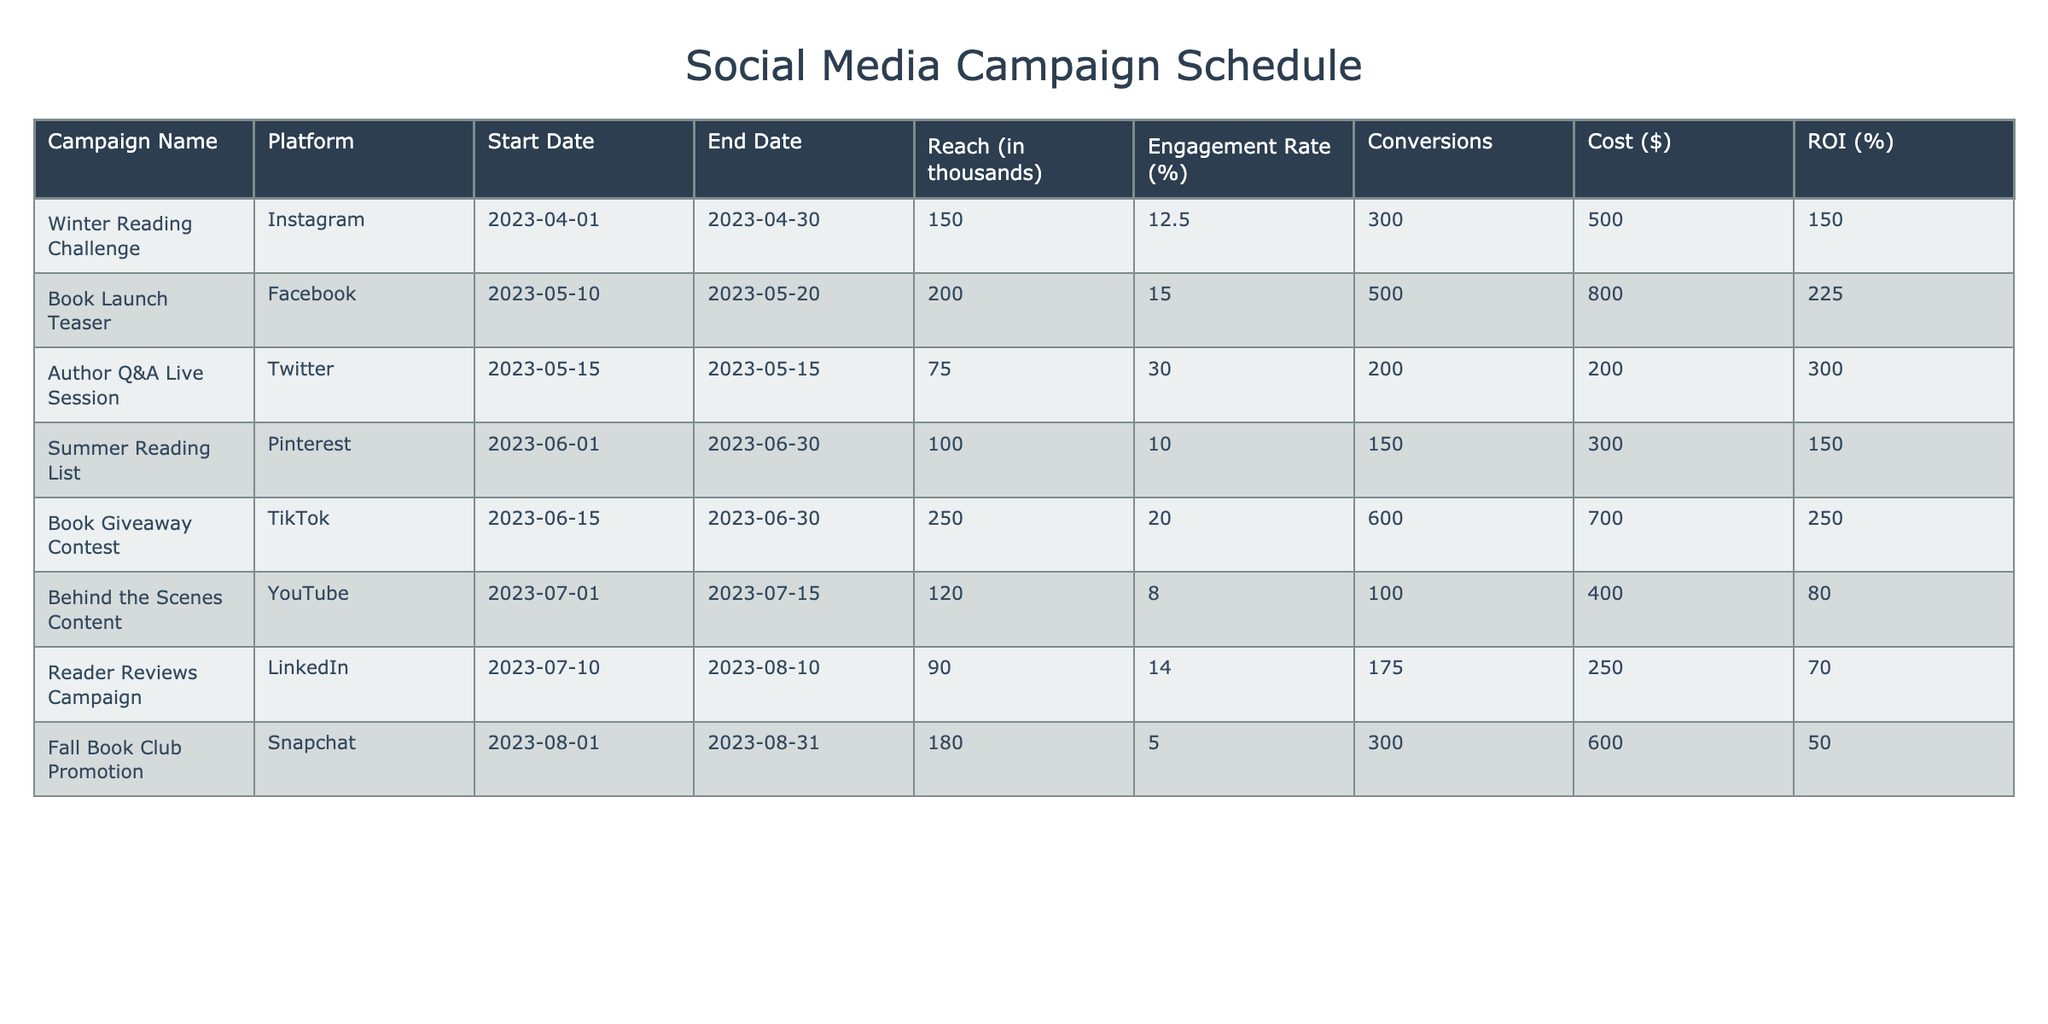What is the engagement rate for the "Book Launch Teaser" campaign? The engagement rate for the "Book Launch Teaser" campaign is listed under the "Engagement Rate (%)" column for that row, which shows a value of 15.0%.
Answer: 15.0% Which campaign had the highest reach in thousands? Looking at the "Reach (in thousands)" column, the "Book Giveaway Contest" campaign has the highest value of 250 thousands.
Answer: 250 What is the total ROI from all campaigns combined? To find the total ROI, we sum up the ROI values from all the campaigns: (150 + 225 + 300 + 150 + 250 + 80 + 70 + 50) = 1275. Thus, the total ROI is 1275%.
Answer: 1275% Did the "Author Q&A Live Session" campaign convert more than the "Fall Book Club Promotion" campaign? The "Author Q&A Live Session" had 200 conversions, while the "Fall Book Club Promotion" had 300 conversions. Since 200 is less than 300, the answer is no.
Answer: No What is the average engagement rate across all campaigns? To find the average engagement rate, we sum the engagement rates: (12.5 + 15.0 + 30.0 + 10.0 + 20.0 + 8.0 + 14.0 + 5.0) = 110.5. Then, we divide by the number of campaigns (8): 110.5 / 8 = 13.8125, rounded to two decimal places it is 13.81%.
Answer: 13.81% Which platform had the highest number of conversions, and how many were achieved? By checking the "Conversions" column, the "Book Giveaway Contest" campaign, which is on TikTok, achieved the highest number of conversions at 600.
Answer: TikTok, 600 Was the "Summer Reading List" campaign more cost-effective than the "Behind the Scenes Content" campaign in terms of ROI? The ROI for "Summer Reading List" is 150% and for "Behind the Scenes Content" it is 80%. Since 150% is greater than 80%, the "Summer Reading List" campaign is more cost-effective.
Answer: Yes What is the difference between the reach of the "Book Launch Teaser" and the "Reader Reviews Campaign"? The "Book Launch Teaser" had a reach of 200 thousands and the "Reader Reviews Campaign" had 90 thousands. The difference is calculated by subtracting: 200 - 90 = 110 thousands.
Answer: 110 How many campaigns had an ROI over 200%? Reviewing the ROI column, the campaigns with ROI over 200% are the "Book Launch Teaser" (225%) and "Author Q&A Live Session" (300%). Thus, there are two campaigns with an ROI over 200%.
Answer: 2 